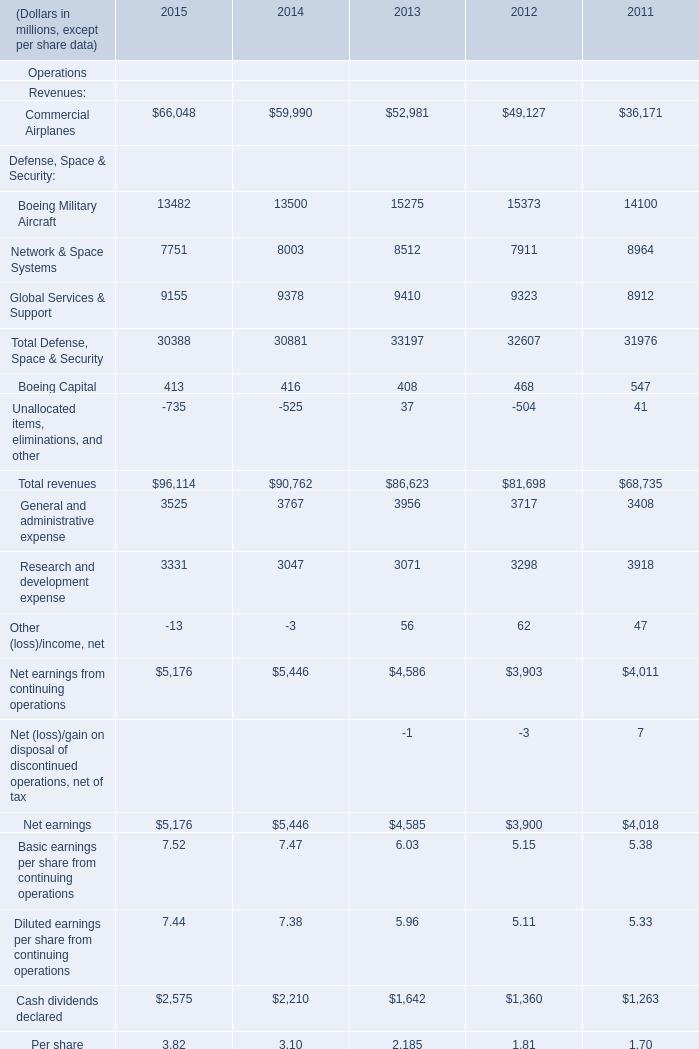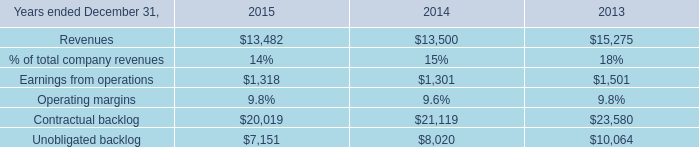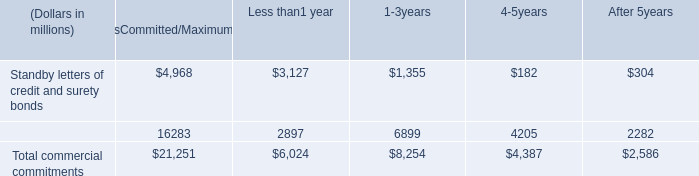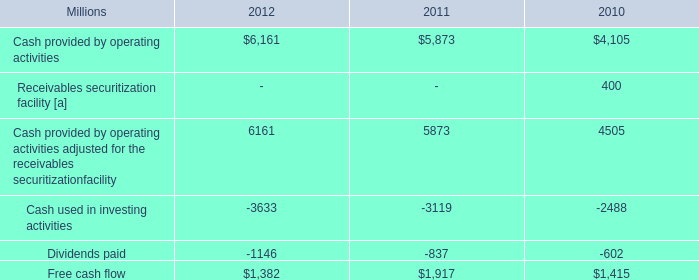What's the total amount of the Network & Space Systems in the years where Global Services & Support is greater than 9400? (in million) 
Answer: 8512. 